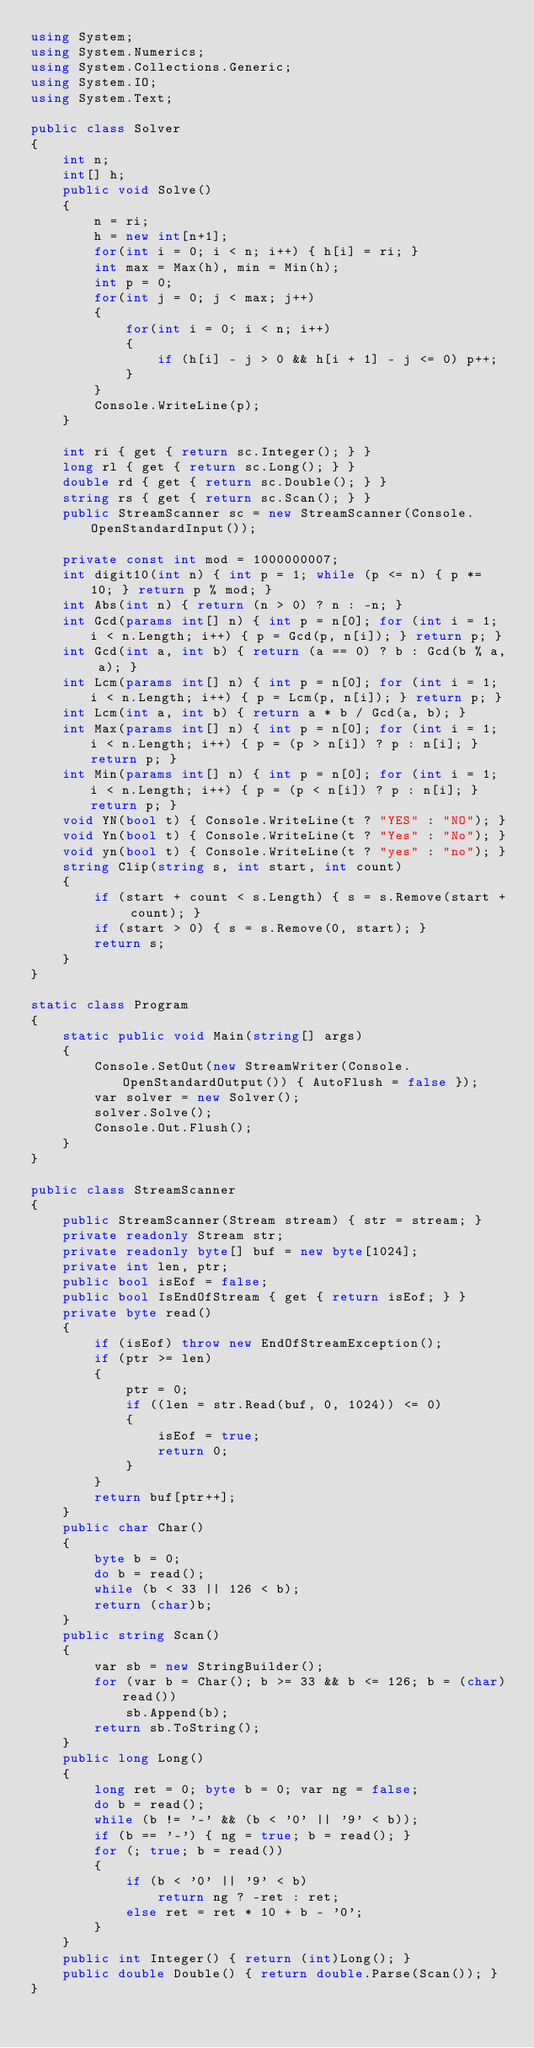Convert code to text. <code><loc_0><loc_0><loc_500><loc_500><_C#_>using System;
using System.Numerics;
using System.Collections.Generic;
using System.IO;
using System.Text;

public class Solver
{
    int n;
    int[] h;
    public void Solve()
    {
        n = ri;
        h = new int[n+1];
        for(int i = 0; i < n; i++) { h[i] = ri; }
        int max = Max(h), min = Min(h);
        int p = 0;
        for(int j = 0; j < max; j++)
        {
            for(int i = 0; i < n; i++)
            {
                if (h[i] - j > 0 && h[i + 1] - j <= 0) p++;
            }
        }
        Console.WriteLine(p);
    }

    int ri { get { return sc.Integer(); } }
    long rl { get { return sc.Long(); } }
    double rd { get { return sc.Double(); } }
    string rs { get { return sc.Scan(); } }
    public StreamScanner sc = new StreamScanner(Console.OpenStandardInput());

    private const int mod = 1000000007;
    int digit10(int n) { int p = 1; while (p <= n) { p *= 10; } return p % mod; }
    int Abs(int n) { return (n > 0) ? n : -n; }
    int Gcd(params int[] n) { int p = n[0]; for (int i = 1; i < n.Length; i++) { p = Gcd(p, n[i]); } return p; }
    int Gcd(int a, int b) { return (a == 0) ? b : Gcd(b % a, a); }
    int Lcm(params int[] n) { int p = n[0]; for (int i = 1; i < n.Length; i++) { p = Lcm(p, n[i]); } return p; }
    int Lcm(int a, int b) { return a * b / Gcd(a, b); }
    int Max(params int[] n) { int p = n[0]; for (int i = 1; i < n.Length; i++) { p = (p > n[i]) ? p : n[i]; } return p; }
    int Min(params int[] n) { int p = n[0]; for (int i = 1; i < n.Length; i++) { p = (p < n[i]) ? p : n[i]; } return p; }
    void YN(bool t) { Console.WriteLine(t ? "YES" : "NO"); }
    void Yn(bool t) { Console.WriteLine(t ? "Yes" : "No"); }
    void yn(bool t) { Console.WriteLine(t ? "yes" : "no"); }
    string Clip(string s, int start, int count)
    {
        if (start + count < s.Length) { s = s.Remove(start + count); }
        if (start > 0) { s = s.Remove(0, start); }
        return s;
    }
}

static class Program
{
    static public void Main(string[] args)
    {
        Console.SetOut(new StreamWriter(Console.OpenStandardOutput()) { AutoFlush = false });
        var solver = new Solver();
        solver.Solve();
        Console.Out.Flush();
    }
}

public class StreamScanner
{
    public StreamScanner(Stream stream) { str = stream; }
    private readonly Stream str;
    private readonly byte[] buf = new byte[1024];
    private int len, ptr;
    public bool isEof = false;
    public bool IsEndOfStream { get { return isEof; } }
    private byte read()
    {
        if (isEof) throw new EndOfStreamException();
        if (ptr >= len)
        {
            ptr = 0;
            if ((len = str.Read(buf, 0, 1024)) <= 0)
            {
                isEof = true;
                return 0;
            }
        }
        return buf[ptr++];
    }
    public char Char()
    {
        byte b = 0;
        do b = read();
        while (b < 33 || 126 < b);
        return (char)b;
    }
    public string Scan()
    {
        var sb = new StringBuilder();
        for (var b = Char(); b >= 33 && b <= 126; b = (char)read())
            sb.Append(b);
        return sb.ToString();
    }
    public long Long()
    {
        long ret = 0; byte b = 0; var ng = false;
        do b = read();
        while (b != '-' && (b < '0' || '9' < b));
        if (b == '-') { ng = true; b = read(); }
        for (; true; b = read())
        {
            if (b < '0' || '9' < b)
                return ng ? -ret : ret;
            else ret = ret * 10 + b - '0';
        }
    }
    public int Integer() { return (int)Long(); }
    public double Double() { return double.Parse(Scan()); }
}</code> 